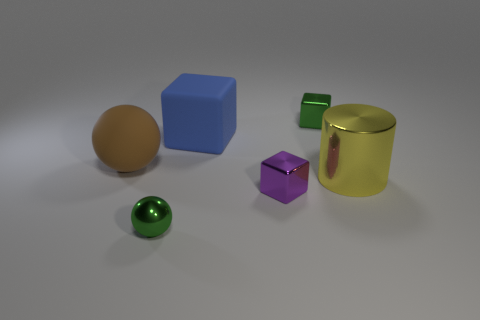What size is the cube that is the same color as the tiny shiny sphere?
Provide a succinct answer. Small. How many objects are either tiny purple metal things or small metallic spheres?
Provide a short and direct response. 2. How many other things are there of the same size as the purple block?
Ensure brevity in your answer.  2. Do the big matte sphere and the shiny object that is left of the blue block have the same color?
Provide a short and direct response. No. How many blocks are either blue things or metal things?
Your response must be concise. 3. Is there anything else that is the same color as the big metal cylinder?
Keep it short and to the point. No. There is a purple block that is in front of the green thing that is behind the metallic sphere; what is its material?
Your answer should be compact. Metal. Do the green cube and the green object that is in front of the large brown rubber ball have the same material?
Ensure brevity in your answer.  Yes. What number of objects are either small green objects to the left of the big blue rubber thing or tiny green cubes?
Keep it short and to the point. 2. Are there any big rubber things of the same color as the matte ball?
Your answer should be very brief. No. 